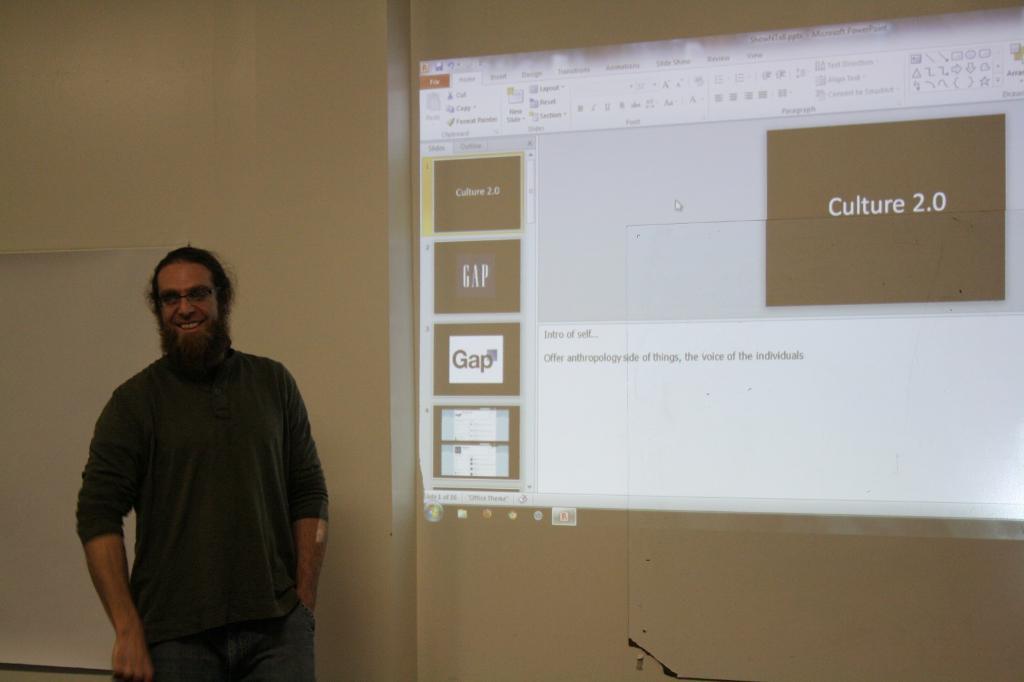Could you give a brief overview of what you see in this image? In this image we can see a man is standing and smiling. He is wearing grey color t-shirt. Behind screen is present. 